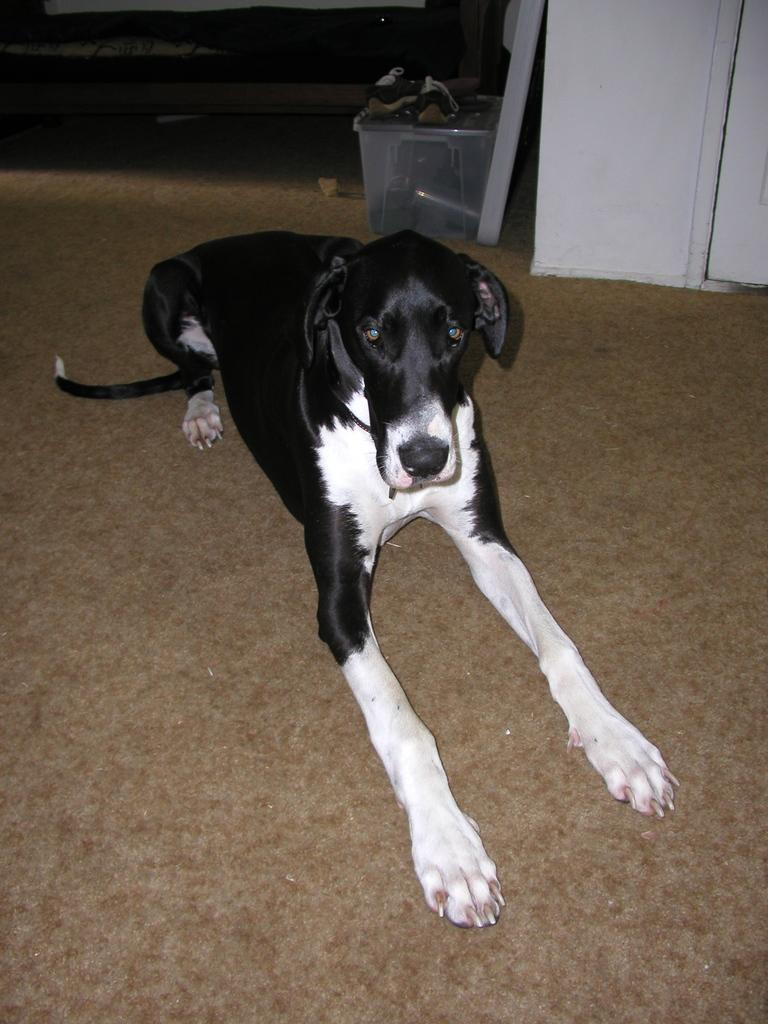What type of animal is in the image? There is a dog in the image. Where is the dog located in the image? The dog is on the floor. What can be seen in the background of the image? There is a box, a wall, and other objects in the background of the image. What type of canvas is the dog using to paint in the image? There is no canvas or painting activity present in the image; it features a dog on the floor. 